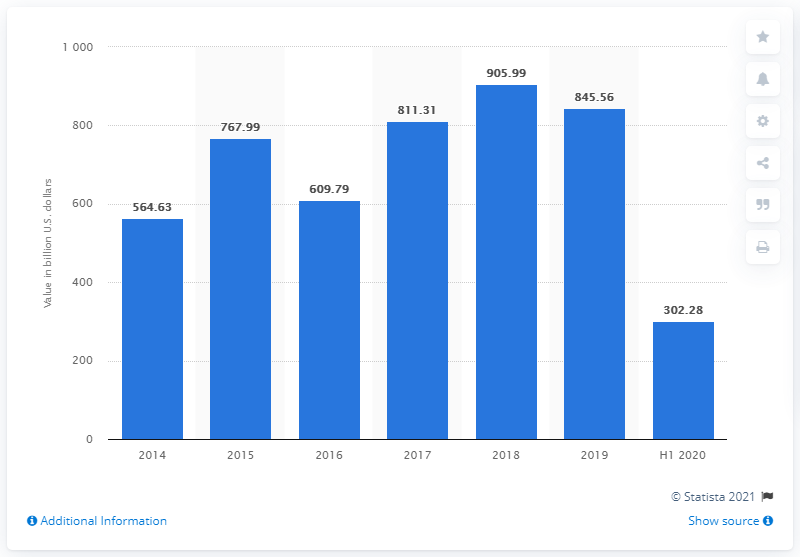Identify some key points in this picture. In the first half of 2020, the value of global private equity deals was 302.28 billion US dollars. 